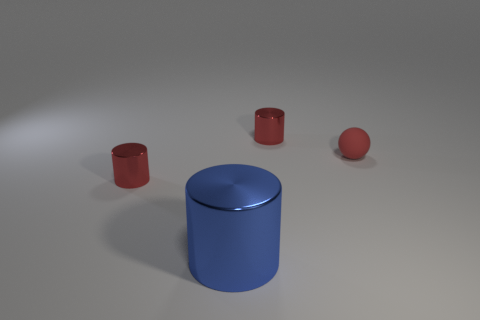Add 2 matte spheres. How many objects exist? 6 Subtract all cylinders. How many objects are left? 1 Subtract all small green rubber blocks. Subtract all small shiny objects. How many objects are left? 2 Add 2 small balls. How many small balls are left? 3 Add 1 tiny rubber balls. How many tiny rubber balls exist? 2 Subtract 0 yellow blocks. How many objects are left? 4 